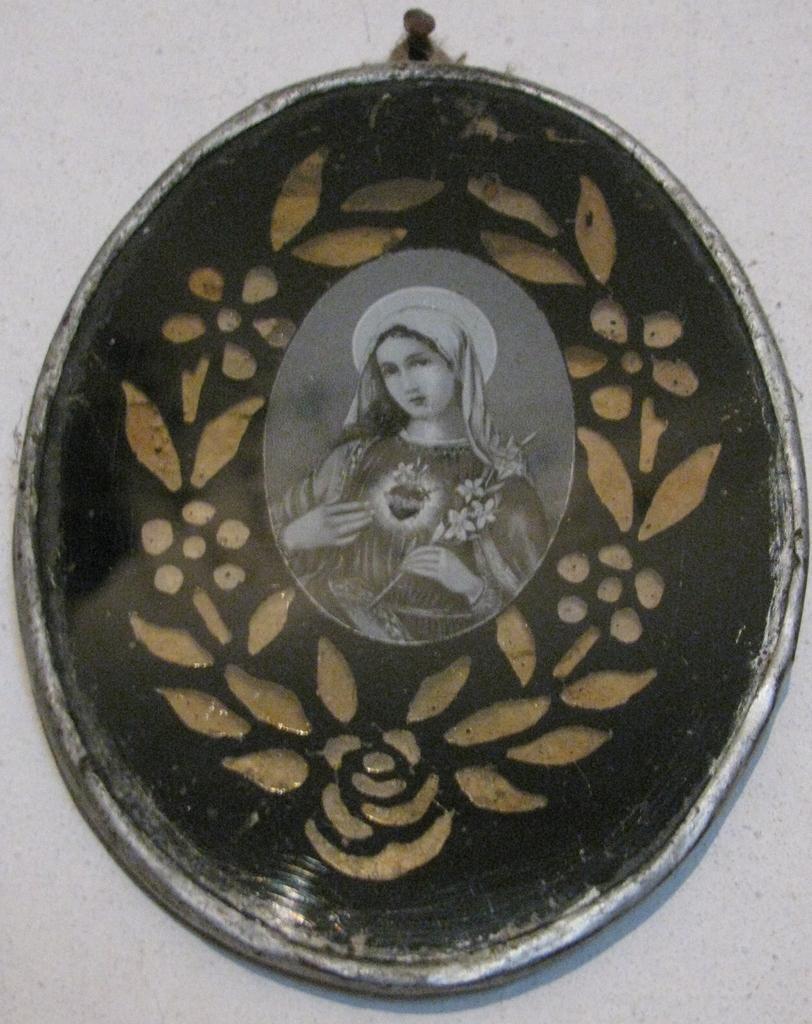Could you give a brief overview of what you see in this image? In this image I can see the frame attached to the wall and I can also see the person in the frame and the wall is in white color. 